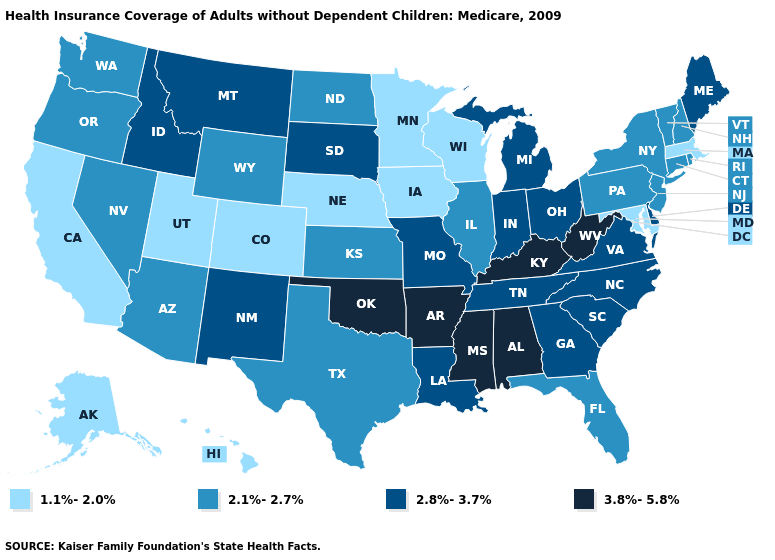Does Tennessee have a higher value than Minnesota?
Give a very brief answer. Yes. Does the map have missing data?
Keep it brief. No. What is the lowest value in the USA?
Answer briefly. 1.1%-2.0%. Among the states that border Maryland , does West Virginia have the lowest value?
Keep it brief. No. What is the value of Virginia?
Keep it brief. 2.8%-3.7%. Does the map have missing data?
Concise answer only. No. What is the lowest value in the South?
Concise answer only. 1.1%-2.0%. Which states have the highest value in the USA?
Write a very short answer. Alabama, Arkansas, Kentucky, Mississippi, Oklahoma, West Virginia. Name the states that have a value in the range 2.1%-2.7%?
Write a very short answer. Arizona, Connecticut, Florida, Illinois, Kansas, Nevada, New Hampshire, New Jersey, New York, North Dakota, Oregon, Pennsylvania, Rhode Island, Texas, Vermont, Washington, Wyoming. What is the lowest value in the USA?
Concise answer only. 1.1%-2.0%. Name the states that have a value in the range 3.8%-5.8%?
Quick response, please. Alabama, Arkansas, Kentucky, Mississippi, Oklahoma, West Virginia. Does Michigan have the lowest value in the USA?
Short answer required. No. Name the states that have a value in the range 3.8%-5.8%?
Keep it brief. Alabama, Arkansas, Kentucky, Mississippi, Oklahoma, West Virginia. Name the states that have a value in the range 2.8%-3.7%?
Keep it brief. Delaware, Georgia, Idaho, Indiana, Louisiana, Maine, Michigan, Missouri, Montana, New Mexico, North Carolina, Ohio, South Carolina, South Dakota, Tennessee, Virginia. Name the states that have a value in the range 2.1%-2.7%?
Give a very brief answer. Arizona, Connecticut, Florida, Illinois, Kansas, Nevada, New Hampshire, New Jersey, New York, North Dakota, Oregon, Pennsylvania, Rhode Island, Texas, Vermont, Washington, Wyoming. 